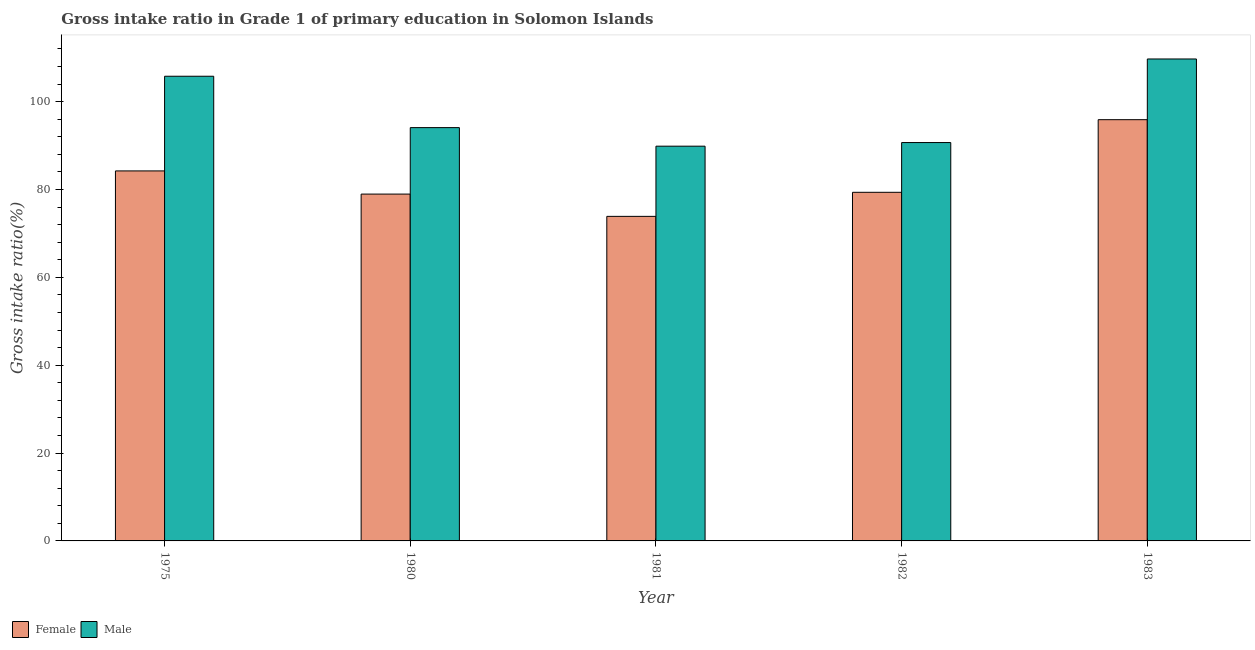How many different coloured bars are there?
Offer a very short reply. 2. Are the number of bars per tick equal to the number of legend labels?
Give a very brief answer. Yes. Are the number of bars on each tick of the X-axis equal?
Offer a terse response. Yes. How many bars are there on the 3rd tick from the left?
Offer a very short reply. 2. What is the label of the 5th group of bars from the left?
Make the answer very short. 1983. In how many cases, is the number of bars for a given year not equal to the number of legend labels?
Keep it short and to the point. 0. What is the gross intake ratio(male) in 1981?
Provide a short and direct response. 89.85. Across all years, what is the maximum gross intake ratio(male)?
Your response must be concise. 109.7. Across all years, what is the minimum gross intake ratio(female)?
Provide a short and direct response. 73.87. In which year was the gross intake ratio(female) minimum?
Offer a terse response. 1981. What is the total gross intake ratio(female) in the graph?
Keep it short and to the point. 412.27. What is the difference between the gross intake ratio(female) in 1975 and that in 1980?
Your response must be concise. 5.27. What is the difference between the gross intake ratio(male) in 1980 and the gross intake ratio(female) in 1983?
Your answer should be very brief. -15.62. What is the average gross intake ratio(male) per year?
Your response must be concise. 98.01. What is the ratio of the gross intake ratio(female) in 1980 to that in 1981?
Your response must be concise. 1.07. Is the gross intake ratio(male) in 1975 less than that in 1981?
Offer a terse response. No. Is the difference between the gross intake ratio(male) in 1975 and 1982 greater than the difference between the gross intake ratio(female) in 1975 and 1982?
Keep it short and to the point. No. What is the difference between the highest and the second highest gross intake ratio(female)?
Your answer should be very brief. 11.66. What is the difference between the highest and the lowest gross intake ratio(male)?
Keep it short and to the point. 19.85. In how many years, is the gross intake ratio(female) greater than the average gross intake ratio(female) taken over all years?
Your answer should be very brief. 2. What does the 1st bar from the left in 1982 represents?
Keep it short and to the point. Female. What is the difference between two consecutive major ticks on the Y-axis?
Your response must be concise. 20. Are the values on the major ticks of Y-axis written in scientific E-notation?
Give a very brief answer. No. Does the graph contain any zero values?
Make the answer very short. No. Does the graph contain grids?
Offer a very short reply. No. Where does the legend appear in the graph?
Provide a short and direct response. Bottom left. How many legend labels are there?
Provide a short and direct response. 2. How are the legend labels stacked?
Make the answer very short. Horizontal. What is the title of the graph?
Offer a very short reply. Gross intake ratio in Grade 1 of primary education in Solomon Islands. What is the label or title of the X-axis?
Make the answer very short. Year. What is the label or title of the Y-axis?
Your answer should be very brief. Gross intake ratio(%). What is the Gross intake ratio(%) in Female in 1975?
Keep it short and to the point. 84.22. What is the Gross intake ratio(%) of Male in 1975?
Make the answer very short. 105.77. What is the Gross intake ratio(%) of Female in 1980?
Your answer should be compact. 78.95. What is the Gross intake ratio(%) in Male in 1980?
Your answer should be compact. 94.07. What is the Gross intake ratio(%) of Female in 1981?
Keep it short and to the point. 73.87. What is the Gross intake ratio(%) of Male in 1981?
Ensure brevity in your answer.  89.85. What is the Gross intake ratio(%) in Female in 1982?
Your answer should be compact. 79.35. What is the Gross intake ratio(%) of Male in 1982?
Make the answer very short. 90.67. What is the Gross intake ratio(%) of Female in 1983?
Ensure brevity in your answer.  95.88. What is the Gross intake ratio(%) of Male in 1983?
Make the answer very short. 109.7. Across all years, what is the maximum Gross intake ratio(%) in Female?
Offer a terse response. 95.88. Across all years, what is the maximum Gross intake ratio(%) in Male?
Provide a short and direct response. 109.7. Across all years, what is the minimum Gross intake ratio(%) of Female?
Your answer should be very brief. 73.87. Across all years, what is the minimum Gross intake ratio(%) in Male?
Your answer should be very brief. 89.85. What is the total Gross intake ratio(%) in Female in the graph?
Ensure brevity in your answer.  412.27. What is the total Gross intake ratio(%) of Male in the graph?
Give a very brief answer. 490.07. What is the difference between the Gross intake ratio(%) of Female in 1975 and that in 1980?
Make the answer very short. 5.27. What is the difference between the Gross intake ratio(%) in Male in 1975 and that in 1980?
Provide a succinct answer. 11.69. What is the difference between the Gross intake ratio(%) in Female in 1975 and that in 1981?
Make the answer very short. 10.35. What is the difference between the Gross intake ratio(%) of Male in 1975 and that in 1981?
Your response must be concise. 15.92. What is the difference between the Gross intake ratio(%) in Female in 1975 and that in 1982?
Keep it short and to the point. 4.87. What is the difference between the Gross intake ratio(%) of Male in 1975 and that in 1982?
Ensure brevity in your answer.  15.1. What is the difference between the Gross intake ratio(%) of Female in 1975 and that in 1983?
Offer a very short reply. -11.66. What is the difference between the Gross intake ratio(%) in Male in 1975 and that in 1983?
Your response must be concise. -3.93. What is the difference between the Gross intake ratio(%) in Female in 1980 and that in 1981?
Provide a short and direct response. 5.07. What is the difference between the Gross intake ratio(%) of Male in 1980 and that in 1981?
Your answer should be compact. 4.23. What is the difference between the Gross intake ratio(%) of Female in 1980 and that in 1982?
Your answer should be very brief. -0.41. What is the difference between the Gross intake ratio(%) of Male in 1980 and that in 1982?
Make the answer very short. 3.4. What is the difference between the Gross intake ratio(%) in Female in 1980 and that in 1983?
Your answer should be very brief. -16.94. What is the difference between the Gross intake ratio(%) in Male in 1980 and that in 1983?
Offer a very short reply. -15.62. What is the difference between the Gross intake ratio(%) of Female in 1981 and that in 1982?
Your answer should be very brief. -5.48. What is the difference between the Gross intake ratio(%) in Male in 1981 and that in 1982?
Give a very brief answer. -0.82. What is the difference between the Gross intake ratio(%) of Female in 1981 and that in 1983?
Offer a very short reply. -22.01. What is the difference between the Gross intake ratio(%) in Male in 1981 and that in 1983?
Your response must be concise. -19.85. What is the difference between the Gross intake ratio(%) in Female in 1982 and that in 1983?
Your answer should be very brief. -16.53. What is the difference between the Gross intake ratio(%) in Male in 1982 and that in 1983?
Give a very brief answer. -19.03. What is the difference between the Gross intake ratio(%) in Female in 1975 and the Gross intake ratio(%) in Male in 1980?
Provide a short and direct response. -9.86. What is the difference between the Gross intake ratio(%) in Female in 1975 and the Gross intake ratio(%) in Male in 1981?
Offer a terse response. -5.63. What is the difference between the Gross intake ratio(%) of Female in 1975 and the Gross intake ratio(%) of Male in 1982?
Offer a very short reply. -6.46. What is the difference between the Gross intake ratio(%) in Female in 1975 and the Gross intake ratio(%) in Male in 1983?
Provide a succinct answer. -25.48. What is the difference between the Gross intake ratio(%) of Female in 1980 and the Gross intake ratio(%) of Male in 1981?
Provide a short and direct response. -10.9. What is the difference between the Gross intake ratio(%) of Female in 1980 and the Gross intake ratio(%) of Male in 1982?
Offer a very short reply. -11.73. What is the difference between the Gross intake ratio(%) of Female in 1980 and the Gross intake ratio(%) of Male in 1983?
Provide a short and direct response. -30.75. What is the difference between the Gross intake ratio(%) of Female in 1981 and the Gross intake ratio(%) of Male in 1982?
Offer a very short reply. -16.8. What is the difference between the Gross intake ratio(%) in Female in 1981 and the Gross intake ratio(%) in Male in 1983?
Give a very brief answer. -35.83. What is the difference between the Gross intake ratio(%) in Female in 1982 and the Gross intake ratio(%) in Male in 1983?
Offer a terse response. -30.35. What is the average Gross intake ratio(%) in Female per year?
Ensure brevity in your answer.  82.45. What is the average Gross intake ratio(%) of Male per year?
Give a very brief answer. 98.01. In the year 1975, what is the difference between the Gross intake ratio(%) in Female and Gross intake ratio(%) in Male?
Give a very brief answer. -21.55. In the year 1980, what is the difference between the Gross intake ratio(%) in Female and Gross intake ratio(%) in Male?
Make the answer very short. -15.13. In the year 1981, what is the difference between the Gross intake ratio(%) in Female and Gross intake ratio(%) in Male?
Give a very brief answer. -15.98. In the year 1982, what is the difference between the Gross intake ratio(%) of Female and Gross intake ratio(%) of Male?
Your answer should be very brief. -11.32. In the year 1983, what is the difference between the Gross intake ratio(%) in Female and Gross intake ratio(%) in Male?
Your answer should be compact. -13.82. What is the ratio of the Gross intake ratio(%) of Female in 1975 to that in 1980?
Your response must be concise. 1.07. What is the ratio of the Gross intake ratio(%) in Male in 1975 to that in 1980?
Keep it short and to the point. 1.12. What is the ratio of the Gross intake ratio(%) in Female in 1975 to that in 1981?
Provide a succinct answer. 1.14. What is the ratio of the Gross intake ratio(%) in Male in 1975 to that in 1981?
Provide a short and direct response. 1.18. What is the ratio of the Gross intake ratio(%) of Female in 1975 to that in 1982?
Make the answer very short. 1.06. What is the ratio of the Gross intake ratio(%) in Male in 1975 to that in 1982?
Provide a short and direct response. 1.17. What is the ratio of the Gross intake ratio(%) in Female in 1975 to that in 1983?
Give a very brief answer. 0.88. What is the ratio of the Gross intake ratio(%) in Male in 1975 to that in 1983?
Make the answer very short. 0.96. What is the ratio of the Gross intake ratio(%) of Female in 1980 to that in 1981?
Give a very brief answer. 1.07. What is the ratio of the Gross intake ratio(%) in Male in 1980 to that in 1981?
Make the answer very short. 1.05. What is the ratio of the Gross intake ratio(%) in Female in 1980 to that in 1982?
Offer a terse response. 0.99. What is the ratio of the Gross intake ratio(%) of Male in 1980 to that in 1982?
Offer a very short reply. 1.04. What is the ratio of the Gross intake ratio(%) of Female in 1980 to that in 1983?
Offer a terse response. 0.82. What is the ratio of the Gross intake ratio(%) in Male in 1980 to that in 1983?
Give a very brief answer. 0.86. What is the ratio of the Gross intake ratio(%) in Female in 1981 to that in 1982?
Ensure brevity in your answer.  0.93. What is the ratio of the Gross intake ratio(%) of Male in 1981 to that in 1982?
Ensure brevity in your answer.  0.99. What is the ratio of the Gross intake ratio(%) in Female in 1981 to that in 1983?
Offer a terse response. 0.77. What is the ratio of the Gross intake ratio(%) of Male in 1981 to that in 1983?
Your answer should be very brief. 0.82. What is the ratio of the Gross intake ratio(%) of Female in 1982 to that in 1983?
Offer a terse response. 0.83. What is the ratio of the Gross intake ratio(%) of Male in 1982 to that in 1983?
Your answer should be very brief. 0.83. What is the difference between the highest and the second highest Gross intake ratio(%) of Female?
Provide a short and direct response. 11.66. What is the difference between the highest and the second highest Gross intake ratio(%) of Male?
Your answer should be compact. 3.93. What is the difference between the highest and the lowest Gross intake ratio(%) in Female?
Provide a short and direct response. 22.01. What is the difference between the highest and the lowest Gross intake ratio(%) of Male?
Give a very brief answer. 19.85. 